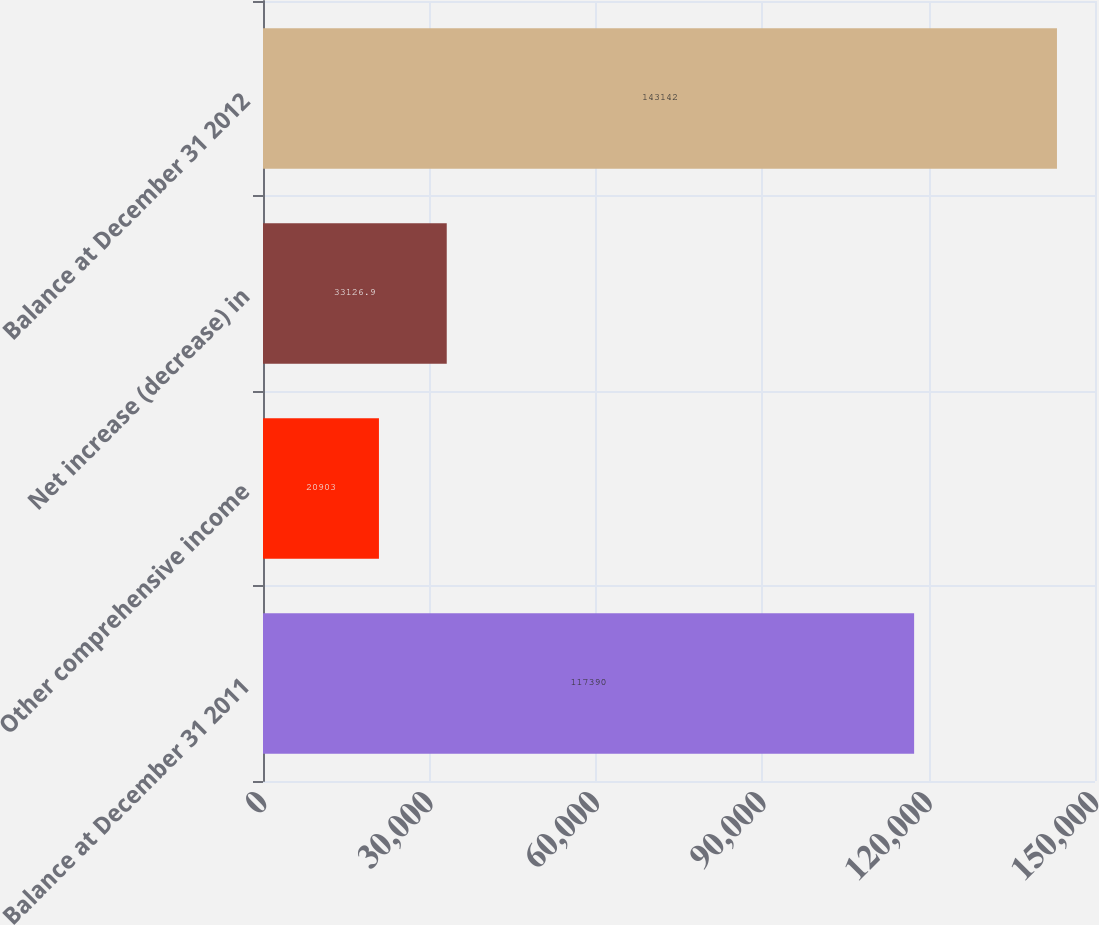Convert chart. <chart><loc_0><loc_0><loc_500><loc_500><bar_chart><fcel>Balance at December 31 2011<fcel>Other comprehensive income<fcel>Net increase (decrease) in<fcel>Balance at December 31 2012<nl><fcel>117390<fcel>20903<fcel>33126.9<fcel>143142<nl></chart> 